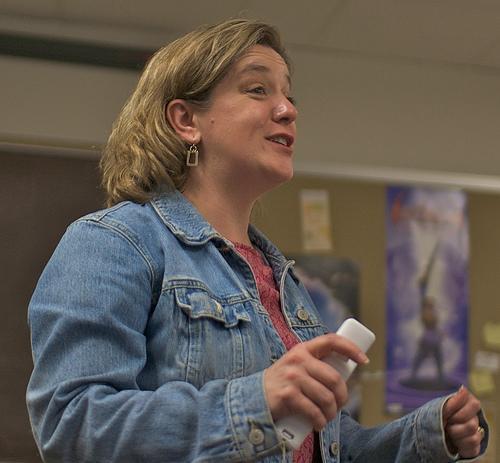How many faces are visible?
Give a very brief answer. 1. 